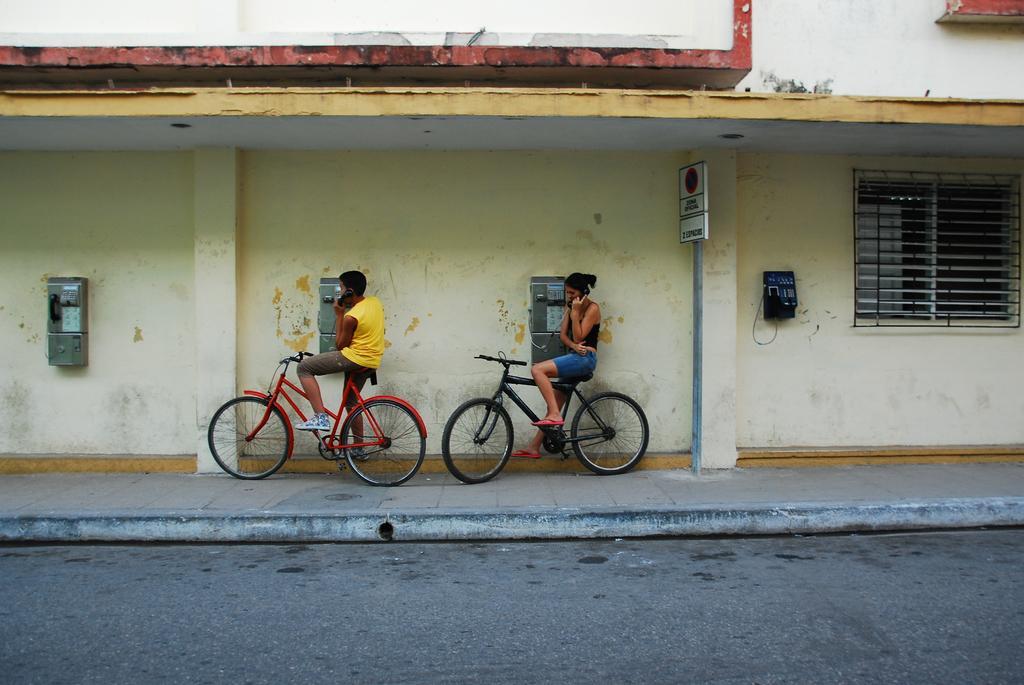Can you describe this image briefly? In this image we can see a building and it is having a window. There are few telephones on the wall of the building. There are few persons and bicycles in the image. There is a footpath in the image. There is a road at the bottom of the image. 